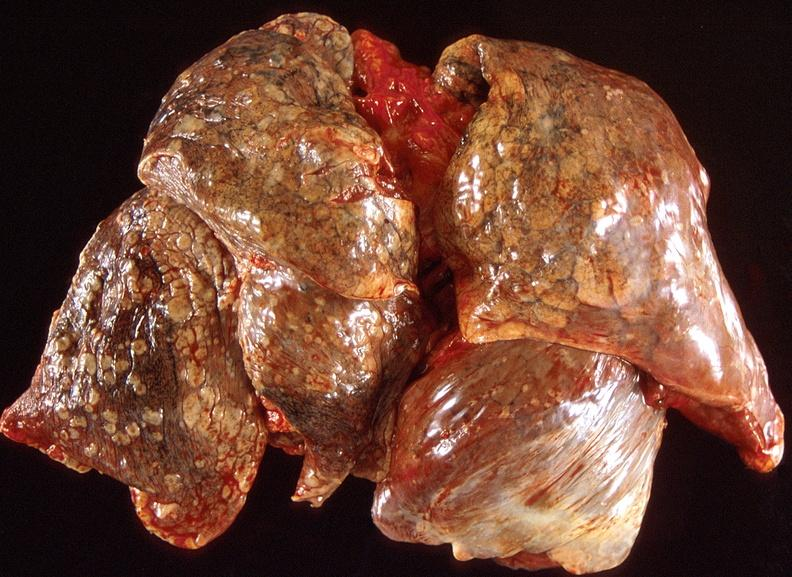does this image show lung carcinoma?
Answer the question using a single word or phrase. Yes 